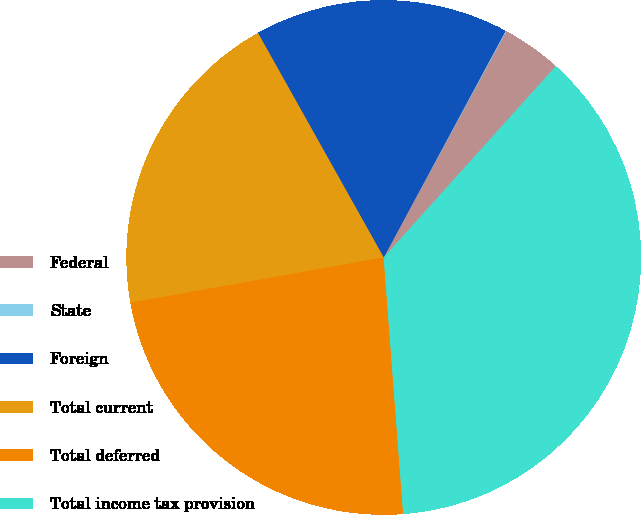<chart> <loc_0><loc_0><loc_500><loc_500><pie_chart><fcel>Federal<fcel>State<fcel>Foreign<fcel>Total current<fcel>Total deferred<fcel>Total income tax provision<nl><fcel>3.76%<fcel>0.05%<fcel>15.98%<fcel>19.69%<fcel>23.39%<fcel>37.13%<nl></chart> 